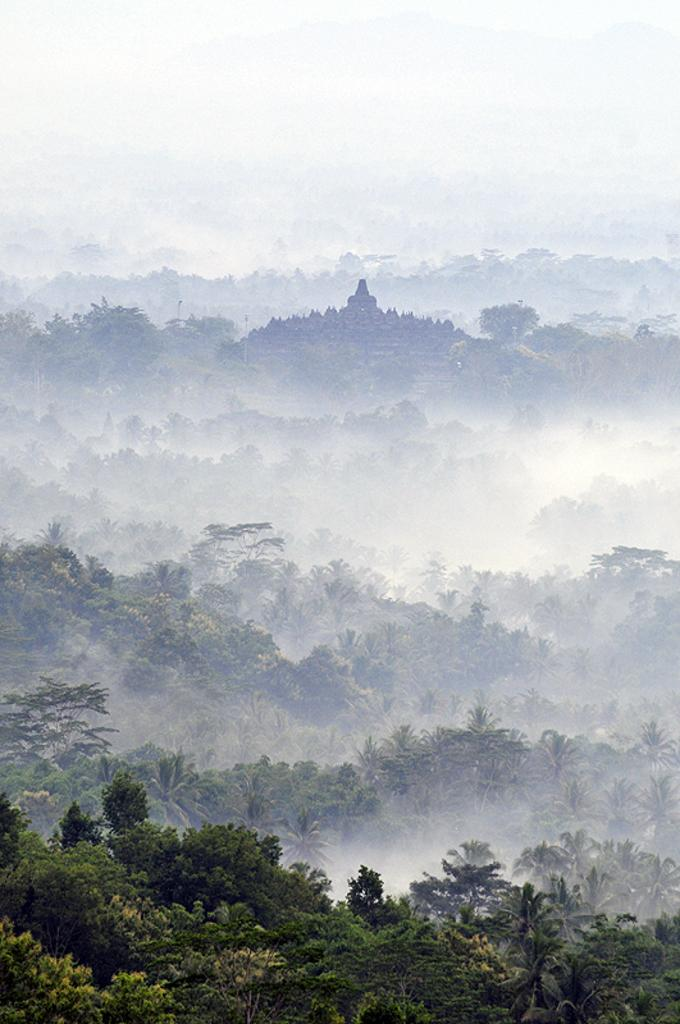What type of natural elements can be seen in the image? There are trees in the image. What atmospheric condition is present in the image? There is fog in the image. What man-made object is visible in the image? There is a pole in the image. What part of the natural environment is visible in the image? The sky is visible in the image. What type of structure can be seen in the image? There is a building in the image. How many eggs are visible on the land in the image? There are no eggs or land present in the image; it features trees, fog, a pole, the sky, and a building. 